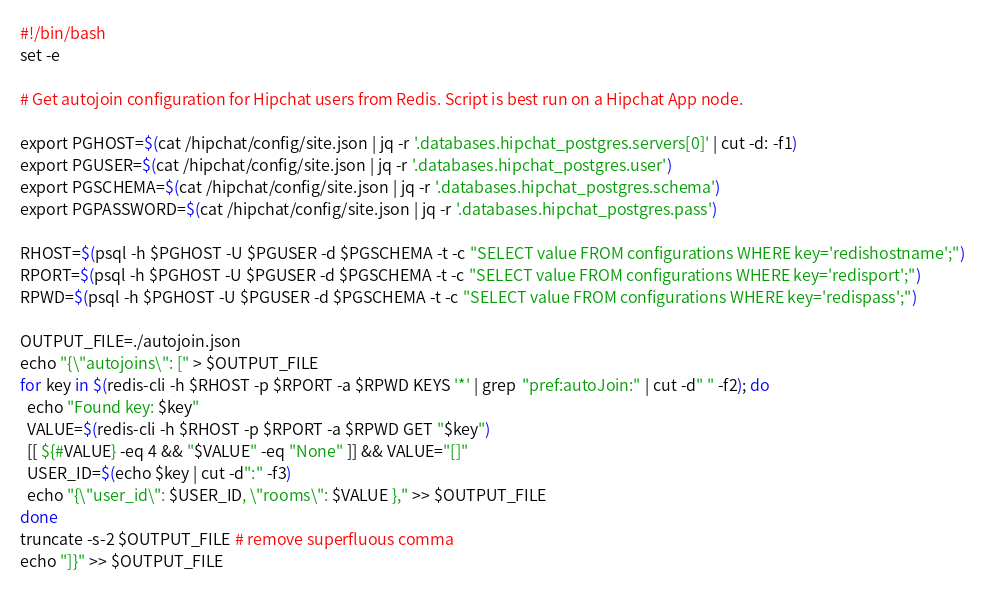Convert code to text. <code><loc_0><loc_0><loc_500><loc_500><_Bash_>#!/bin/bash
set -e

# Get autojoin configuration for Hipchat users from Redis. Script is best run on a Hipchat App node.

export PGHOST=$(cat /hipchat/config/site.json | jq -r '.databases.hipchat_postgres.servers[0]' | cut -d: -f1)
export PGUSER=$(cat /hipchat/config/site.json | jq -r '.databases.hipchat_postgres.user')
export PGSCHEMA=$(cat /hipchat/config/site.json | jq -r '.databases.hipchat_postgres.schema')
export PGPASSWORD=$(cat /hipchat/config/site.json | jq -r '.databases.hipchat_postgres.pass')

RHOST=$(psql -h $PGHOST -U $PGUSER -d $PGSCHEMA -t -c "SELECT value FROM configurations WHERE key='redishostname';")
RPORT=$(psql -h $PGHOST -U $PGUSER -d $PGSCHEMA -t -c "SELECT value FROM configurations WHERE key='redisport';")
RPWD=$(psql -h $PGHOST -U $PGUSER -d $PGSCHEMA -t -c "SELECT value FROM configurations WHERE key='redispass';")

OUTPUT_FILE=./autojoin.json
echo "{\"autojoins\": [" > $OUTPUT_FILE
for key in $(redis-cli -h $RHOST -p $RPORT -a $RPWD KEYS '*' | grep  "pref:autoJoin:" | cut -d" " -f2); do
  echo "Found key: $key"
  VALUE=$(redis-cli -h $RHOST -p $RPORT -a $RPWD GET "$key")
  [[ ${#VALUE} -eq 4 && "$VALUE" -eq "None" ]] && VALUE="[]"
  USER_ID=$(echo $key | cut -d":" -f3)
  echo "{\"user_id\": $USER_ID, \"rooms\": $VALUE }," >> $OUTPUT_FILE
done
truncate -s-2 $OUTPUT_FILE # remove superfluous comma
echo "]}" >> $OUTPUT_FILE
</code> 